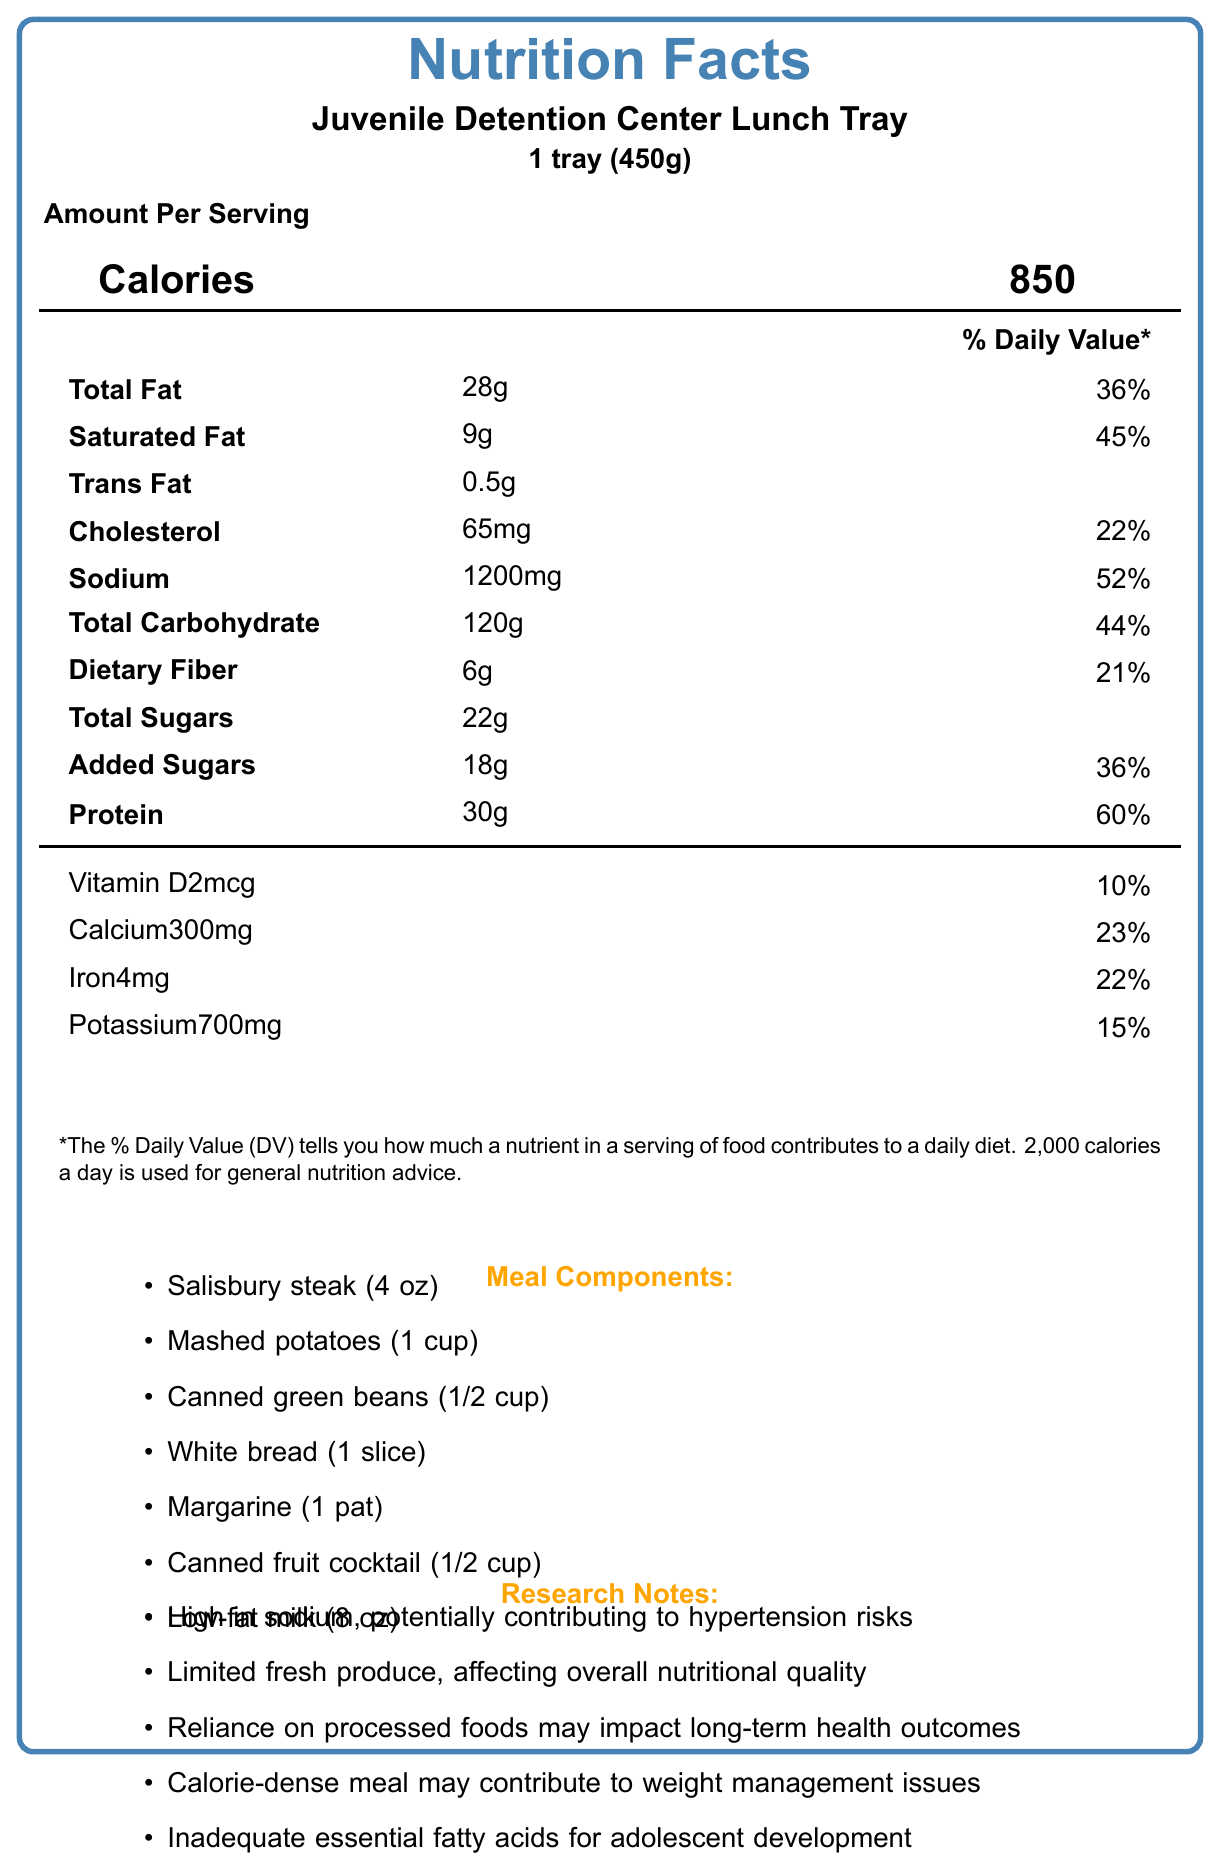what is the serving size for the Juvenile Detention Center Lunch Tray? The serving size is explicitly stated as "1 tray (450g)" under the product name.
Answer: 1 tray (450g) how many calories are in one serving of the Juvenile Detention Center Lunch Tray? The number of calories is listed prominently under the "Calories" heading and is indicated as 850.
Answer: 850 what is the total fat content in grams and its daily value percentage? The total fat content is listed as "Total Fat: 28g" with a daily value percentage of 36%.
Answer: 28g, 36% how much sodium does one serving contain, and what is its daily value percentage? The sodium content is listed as "Sodium: 1200mg" with a daily value percentage of 52%.
Answer: 1200mg, 52% what is the amount of dietary fiber and its percentage of daily value? The dietary fiber amount is listed as "Dietary Fiber: 6g" with a daily value percentage of 21%.
Answer: 6g, 21% based on the document, what are the primary health concerns associated with this meal? A. High sodium content B. High sugar content C. Limited fresh produce D. Calorie-dense meals The research notes mention "High in sodium," "Limited fresh produce," and "Calorie-dense meal," which relate to options A, C, and D.
Answer: A, C, D what items are included in the meal components? A. Salisbury steak B. Broccoli C. Canned fruit cocktail D. White bread The meal components listed include Salisbury steak, canned fruit cocktail, and white bread, so the correct options are A, C, and D.
Answer: A, C, D is there any information on how this meal might impact the weight of the juveniles? The research notes mention that the "Calorie-dense meal may contribute to weight management issues," indicating an impact on weight.
Answer: Yes summarize the main idea of the document. The document outlines the nutritional content, meal components, and associated health concerns of the meal served in juvenile detention centers, with notes on the need for better nutrition standards.
Answer: The document provides nutrition facts for a typical meal served in a juvenile detention center, highlighting the nutritional components, meal items, research notes on health impacts, and policy implications for improving nutritional standards. is the amount of trans fat in this meal high in daily value percentage? The amount of trans fat is listed as 0.5g, but there is no daily value percentage provided, indicating it is not high enough to be noted as significant.
Answer: No, it’s not specified what is the potential impact of the meal's reliance on processed foods? The research notes state that "Reliance on processed foods may impact long-term health outcomes," indicating potential negative health effects over time.
Answer: It may impact long-term health outcomes how much protein does this meal provide, and what percentage of daily value does that represent? The protein content is listed as "Protein: 30g" with a daily value percentage of 60%.
Answer: 30g, 60% which of the following is NOT a component of the meal? A. Low-fat milk B. Fresh apples C. Margarine D. Mashed potatoes Fresh apples are not listed as a meal component; thus, option B is the correct answer.
Answer: B are there any considerations for essential fatty acids mentioned in the document? The research notes mention "Inadequate essential fatty acids for adolescent development," indicating a consideration for nutritional deficiencies.
Answer: Yes how many servings are contained in one tray of this meal? The document states "Servings Per Container: 1," indicating one tray is one serving.
Answer: 1 can it be determined if the juveniles have any special nutritional needs or restrictions from this document? The document does not provide specific details about any special nutritional needs or restrictions for the juveniles.
Answer: No, cannot be determined 